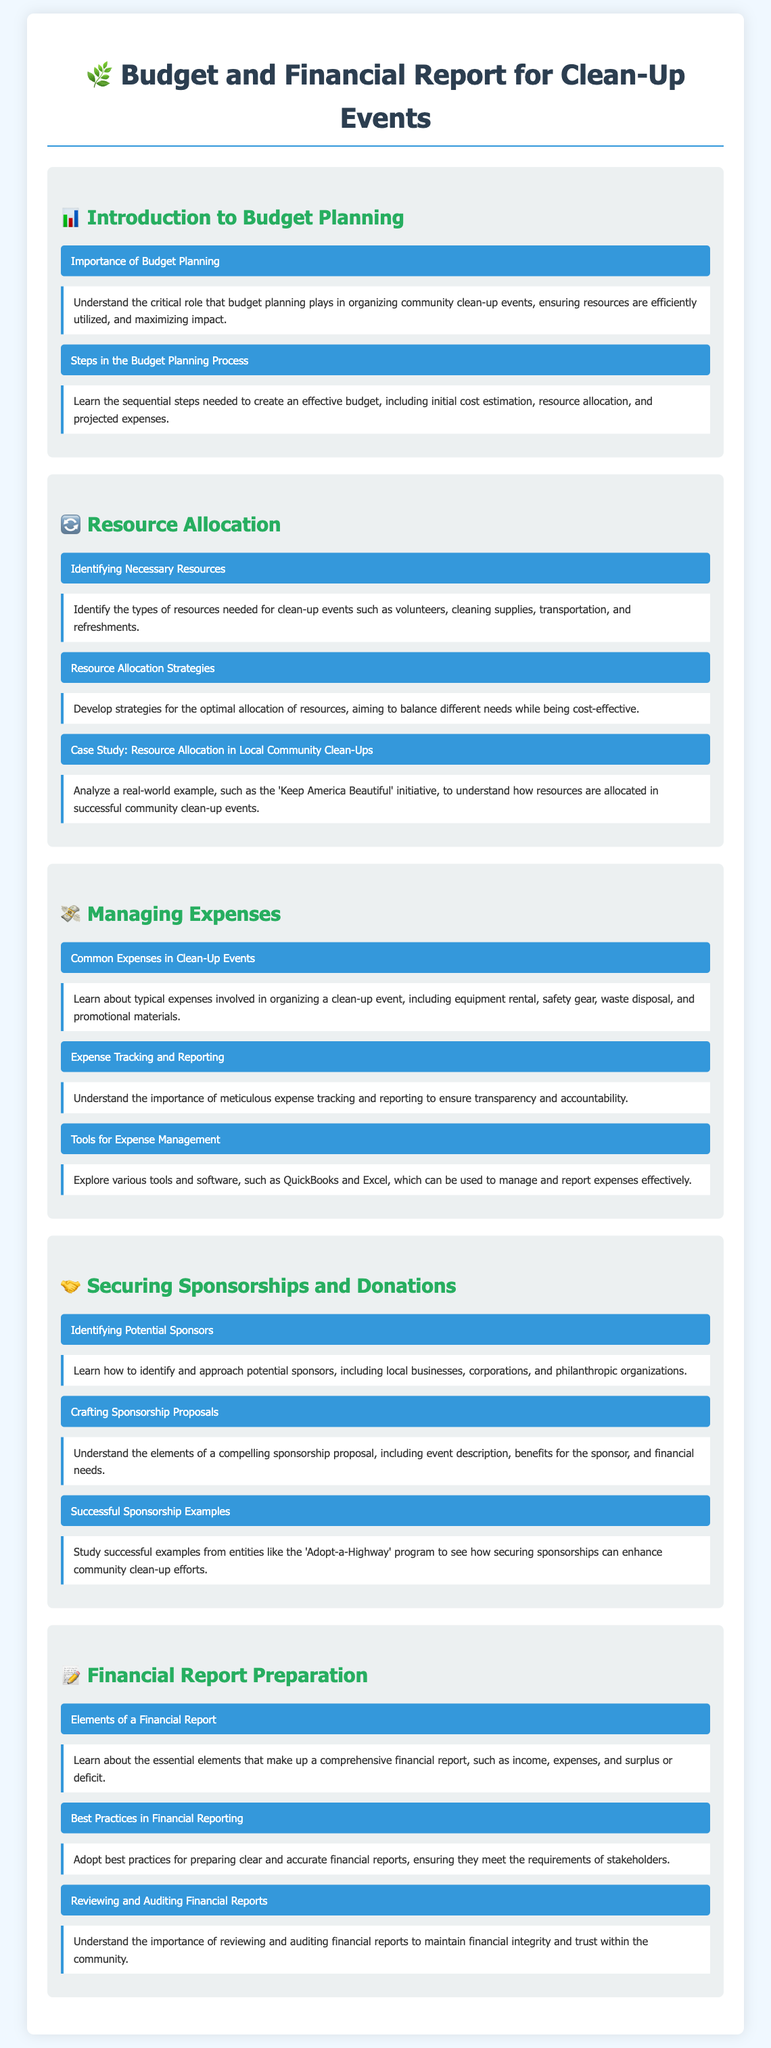What is the title of the document? The title is found at the top of the document, introducing the main subject matter.
Answer: Budget and Financial Report for Clean-Up Events What is one type of resource identified for clean-up events? The document lists necessary resources needed for clean-up events.
Answer: volunteers What is the icon for the section on Managing Expenses? The different sections of the document are represented by unique icons, with each section having a specific icon to visually distinguish them.
Answer: 💸 What tools are mentioned for expense management? The document highlights various tools that can assist in managing finances effectively.
Answer: QuickBooks and Excel Which program is cited as an example for successful sponsorship? The document provides a specific example related to sponsorship that showcases effective community involvement.
Answer: Adopt-a-Highway What is one best practice for financial reporting? The document discusses improved methods for preparing financial documents.
Answer: clear and accurate financial reports How many topics are covered under Securing Sponsorships and Donations? The document lists the number of topics included in this specific section.
Answer: 3 What should a sponsorship proposal include? The document outlines essential contents for crafting a successful sponsorship proposal.
Answer: event description, benefits for the sponsor, and financial needs 